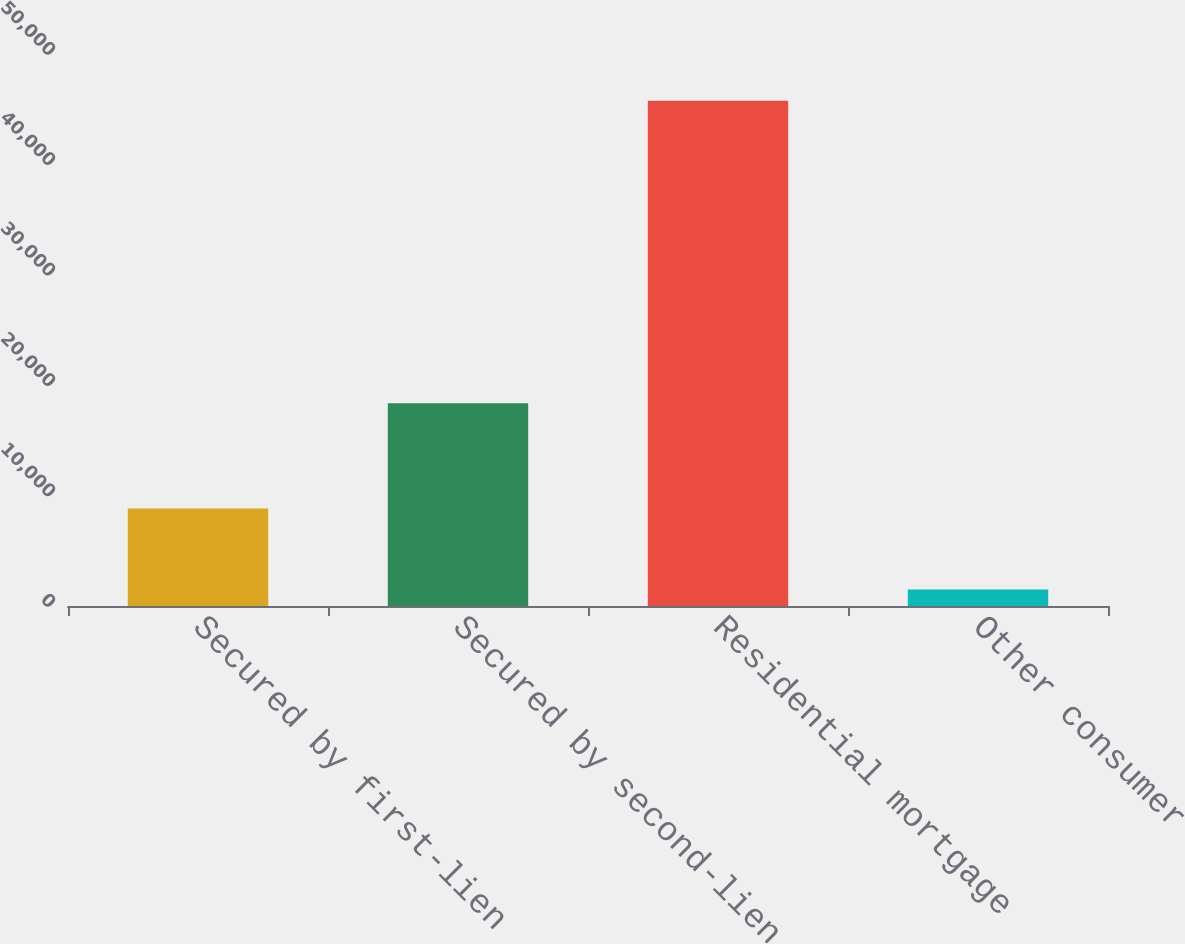<chart> <loc_0><loc_0><loc_500><loc_500><bar_chart><fcel>Secured by first-lien<fcel>Secured by second-lien<fcel>Residential mortgage<fcel>Other consumer<nl><fcel>8822<fcel>18357<fcel>45774<fcel>1502<nl></chart> 